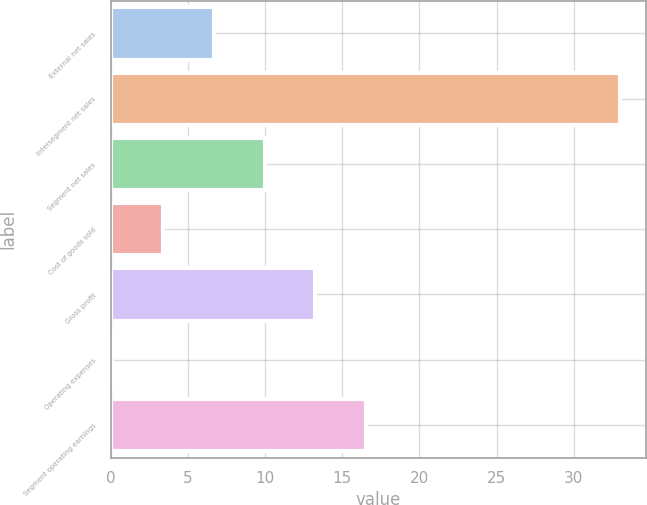Convert chart. <chart><loc_0><loc_0><loc_500><loc_500><bar_chart><fcel>External net sales<fcel>Intersegment net sales<fcel>Segment net sales<fcel>Cost of goods sold<fcel>Gross profit<fcel>Operating expenses<fcel>Segment operating earnings<nl><fcel>6.68<fcel>33<fcel>9.97<fcel>3.39<fcel>13.26<fcel>0.1<fcel>16.55<nl></chart> 